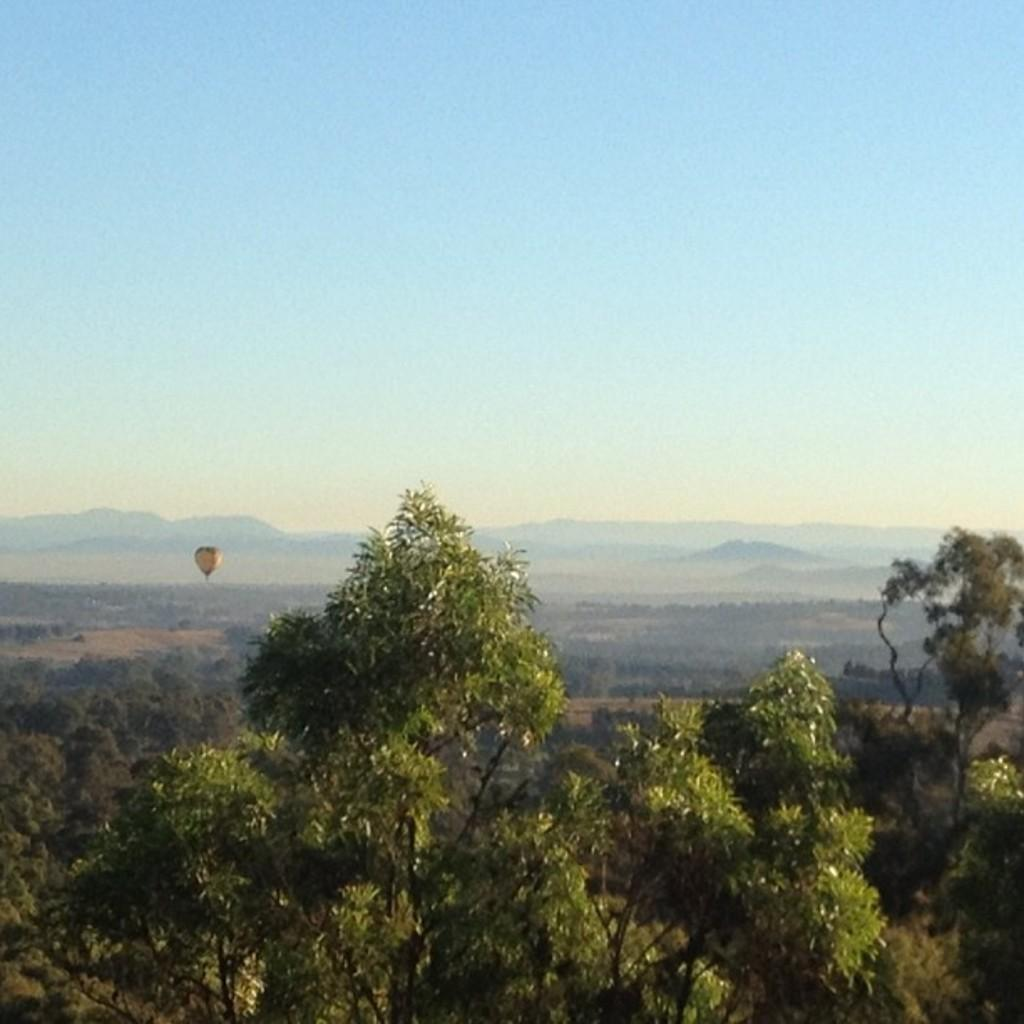What type of vegetation can be seen in the image? There are trees in the image. What is the main object in the sky in the image? There is a hot air balloon in the image. What can be seen in the distance in the image? There are hills visible in the background of the image. What color is the sky in the image? The sky is blue in the image. Where is the structure located in the image? There is no structure mentioned in the provided facts, so we cannot answer this question. What type of field can be seen in the image? There is no field mentioned in the provided facts, so we cannot answer this question. 